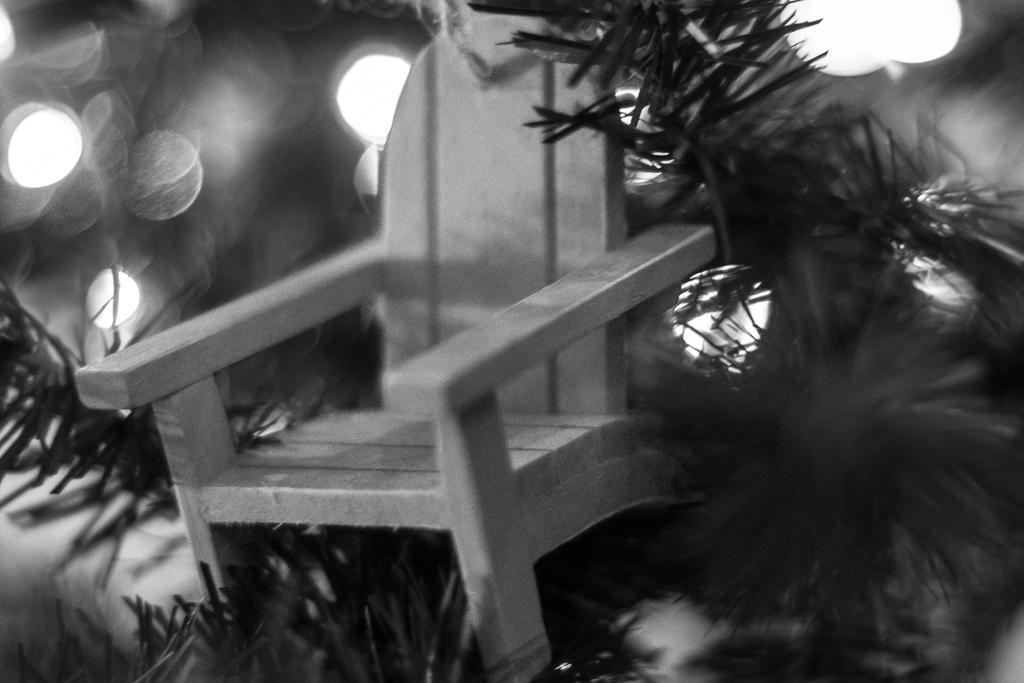Could you give a brief overview of what you see in this image? In this image we can see chair and plants. And the background is blurry. 